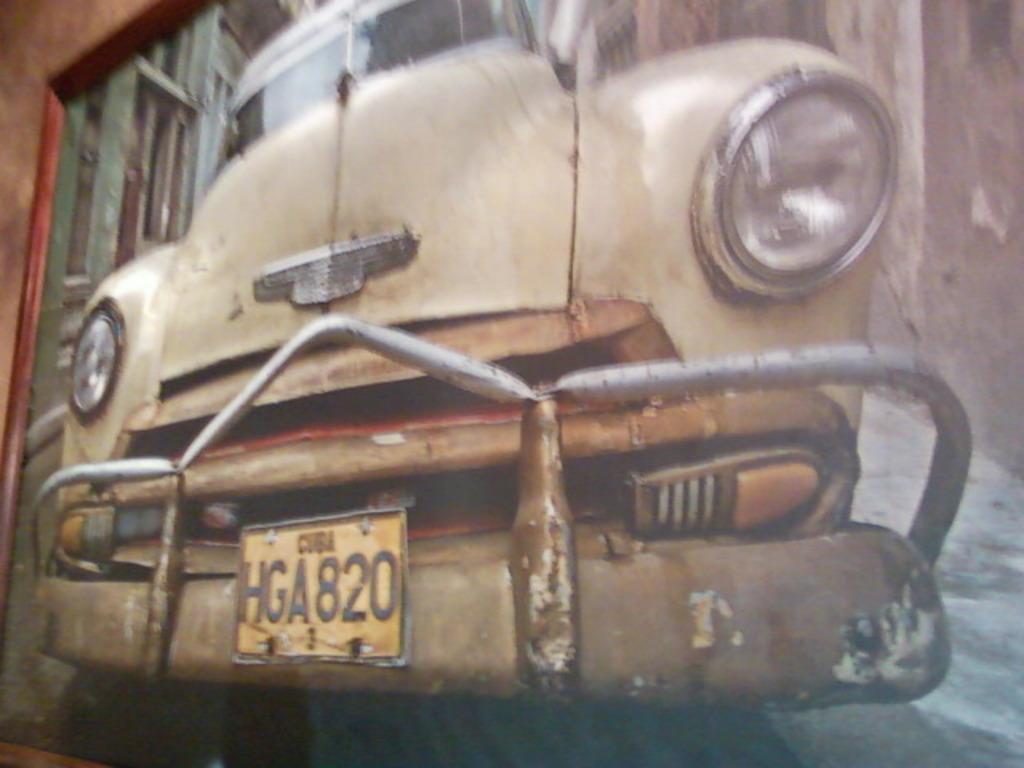Describe this image in one or two sentences. In this image we can see a vehicle with a registration plate, also we can see a building and the wall. 